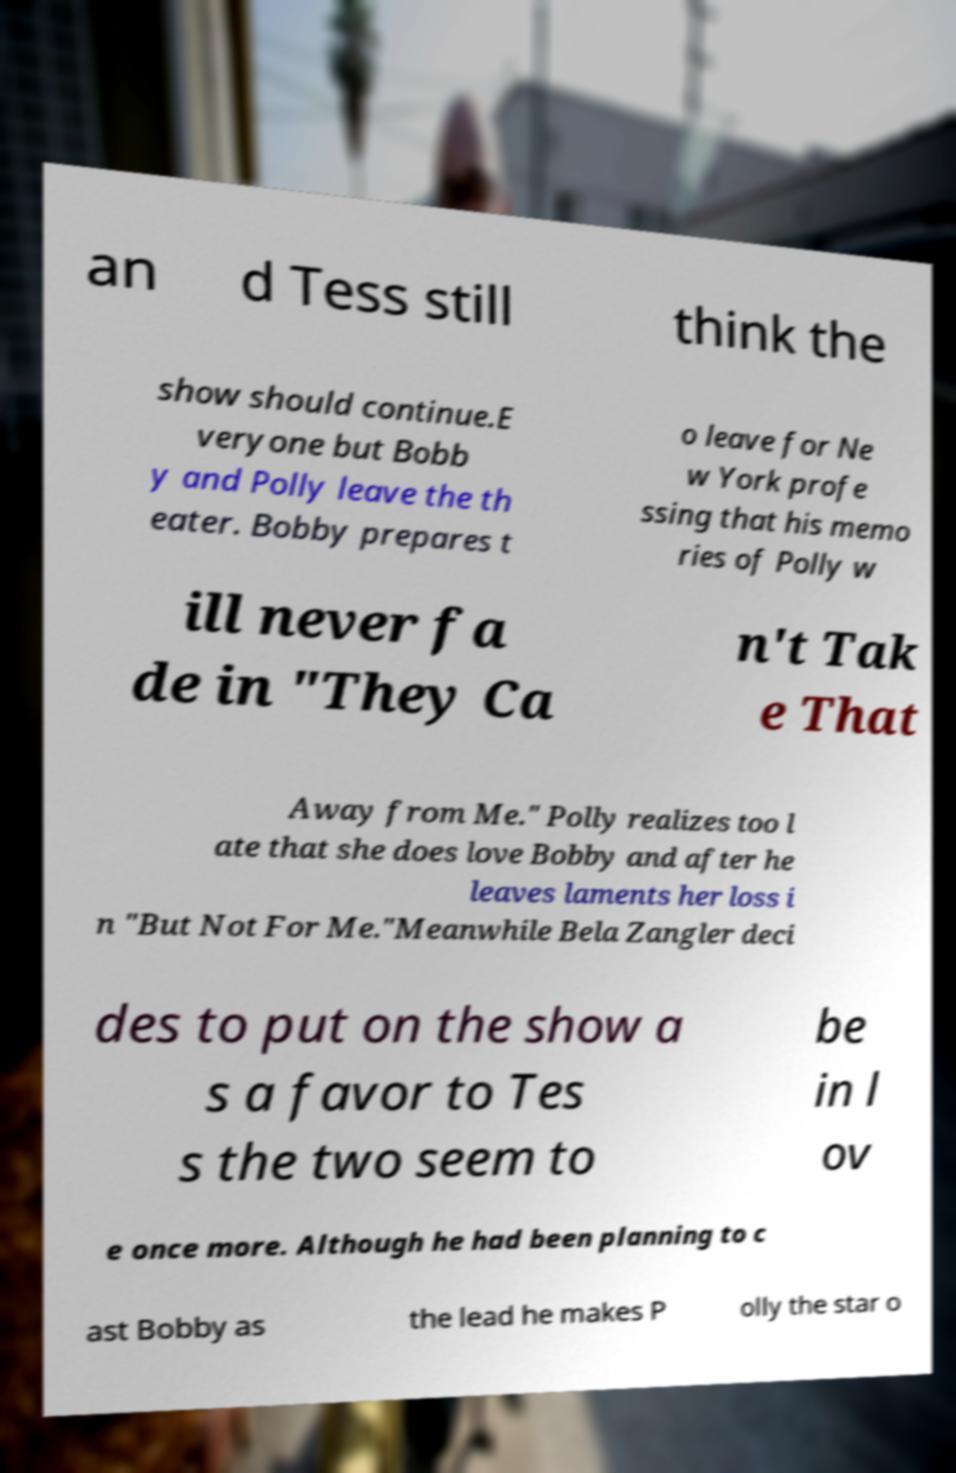What messages or text are displayed in this image? I need them in a readable, typed format. an d Tess still think the show should continue.E veryone but Bobb y and Polly leave the th eater. Bobby prepares t o leave for Ne w York profe ssing that his memo ries of Polly w ill never fa de in "They Ca n't Tak e That Away from Me." Polly realizes too l ate that she does love Bobby and after he leaves laments her loss i n "But Not For Me."Meanwhile Bela Zangler deci des to put on the show a s a favor to Tes s the two seem to be in l ov e once more. Although he had been planning to c ast Bobby as the lead he makes P olly the star o 